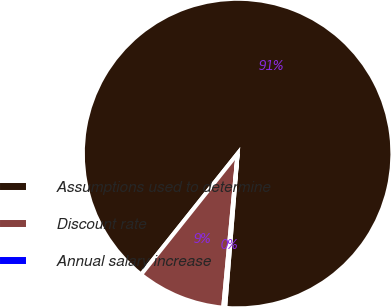Convert chart to OTSL. <chart><loc_0><loc_0><loc_500><loc_500><pie_chart><fcel>Assumptions used to determine<fcel>Discount rate<fcel>Annual salary increase<nl><fcel>90.57%<fcel>9.23%<fcel>0.2%<nl></chart> 